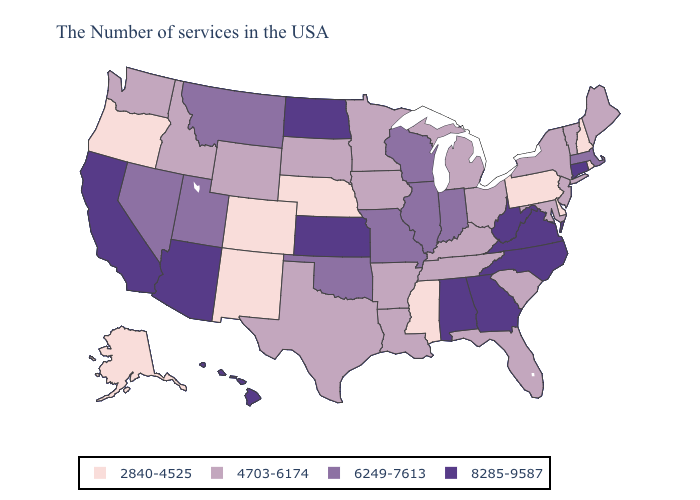Does the map have missing data?
Concise answer only. No. Name the states that have a value in the range 4703-6174?
Write a very short answer. Maine, Vermont, New York, New Jersey, Maryland, South Carolina, Ohio, Florida, Michigan, Kentucky, Tennessee, Louisiana, Arkansas, Minnesota, Iowa, Texas, South Dakota, Wyoming, Idaho, Washington. What is the highest value in the South ?
Quick response, please. 8285-9587. Name the states that have a value in the range 8285-9587?
Write a very short answer. Connecticut, Virginia, North Carolina, West Virginia, Georgia, Alabama, Kansas, North Dakota, Arizona, California, Hawaii. Name the states that have a value in the range 4703-6174?
Keep it brief. Maine, Vermont, New York, New Jersey, Maryland, South Carolina, Ohio, Florida, Michigan, Kentucky, Tennessee, Louisiana, Arkansas, Minnesota, Iowa, Texas, South Dakota, Wyoming, Idaho, Washington. Name the states that have a value in the range 4703-6174?
Keep it brief. Maine, Vermont, New York, New Jersey, Maryland, South Carolina, Ohio, Florida, Michigan, Kentucky, Tennessee, Louisiana, Arkansas, Minnesota, Iowa, Texas, South Dakota, Wyoming, Idaho, Washington. Does New Jersey have a higher value than Alaska?
Be succinct. Yes. Name the states that have a value in the range 2840-4525?
Quick response, please. Rhode Island, New Hampshire, Delaware, Pennsylvania, Mississippi, Nebraska, Colorado, New Mexico, Oregon, Alaska. Name the states that have a value in the range 2840-4525?
Concise answer only. Rhode Island, New Hampshire, Delaware, Pennsylvania, Mississippi, Nebraska, Colorado, New Mexico, Oregon, Alaska. How many symbols are there in the legend?
Short answer required. 4. What is the highest value in the USA?
Be succinct. 8285-9587. Among the states that border Michigan , does Indiana have the highest value?
Give a very brief answer. Yes. Does Arizona have a higher value than Connecticut?
Concise answer only. No. Does Tennessee have the highest value in the South?
Write a very short answer. No. Name the states that have a value in the range 2840-4525?
Answer briefly. Rhode Island, New Hampshire, Delaware, Pennsylvania, Mississippi, Nebraska, Colorado, New Mexico, Oregon, Alaska. 